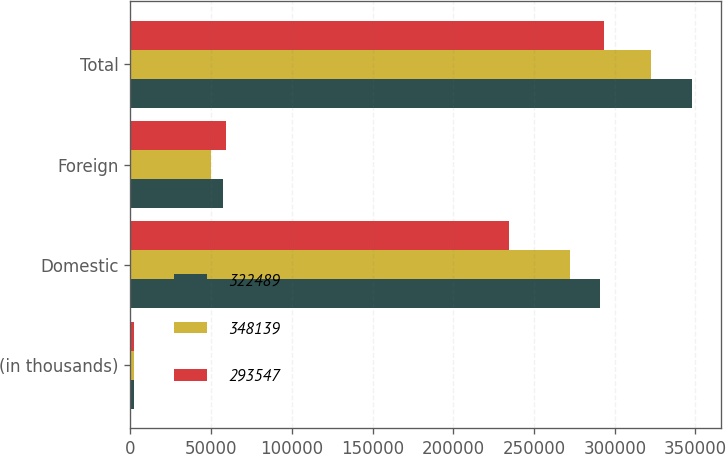<chart> <loc_0><loc_0><loc_500><loc_500><stacked_bar_chart><ecel><fcel>(in thousands)<fcel>Domestic<fcel>Foreign<fcel>Total<nl><fcel>322489<fcel>2014<fcel>291042<fcel>57097<fcel>348139<nl><fcel>348139<fcel>2013<fcel>272569<fcel>49920<fcel>322489<nl><fcel>293547<fcel>2012<fcel>234497<fcel>59050<fcel>293547<nl></chart> 